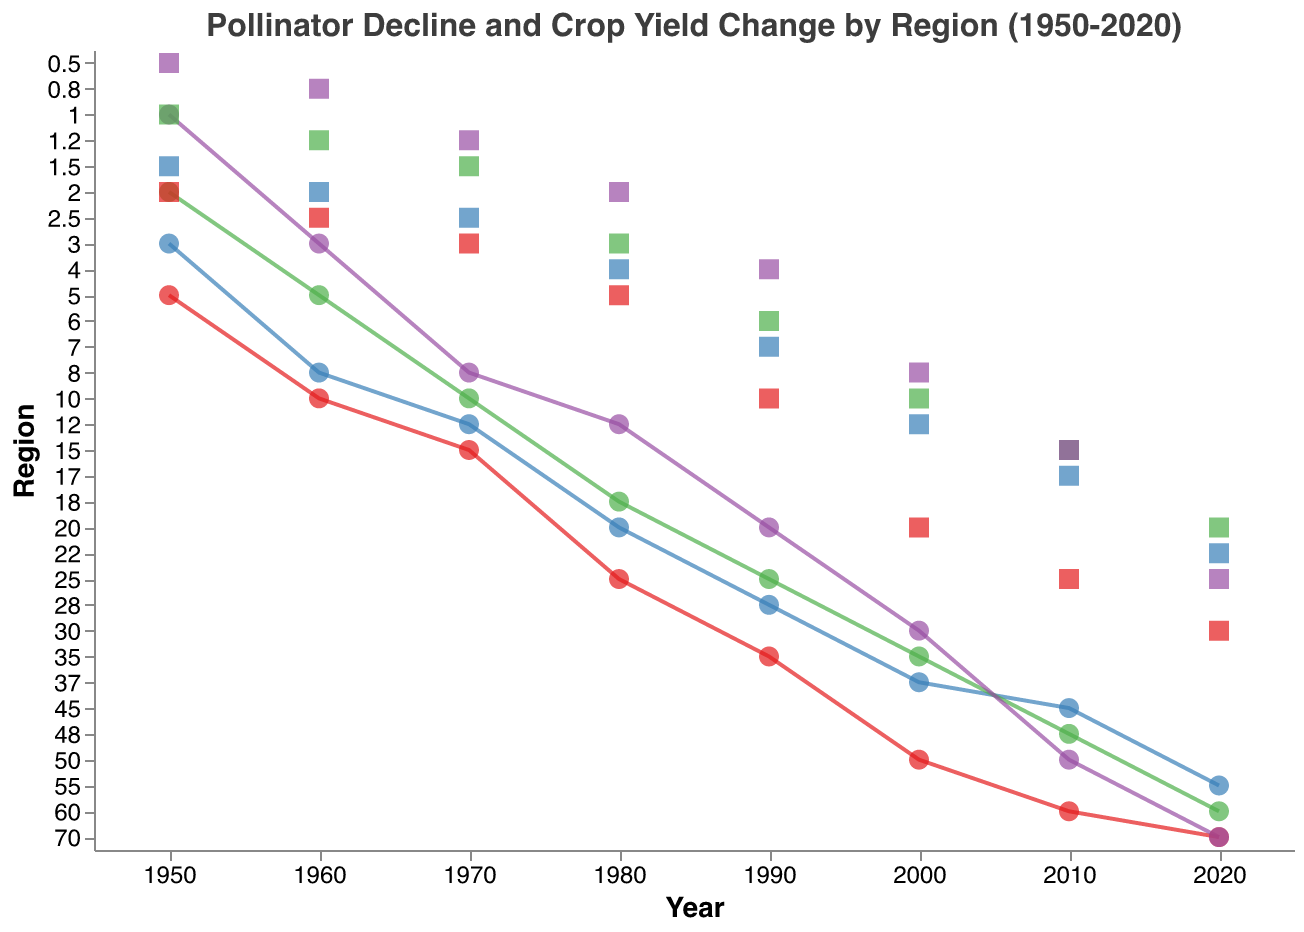What's the main title of the figure? The main title of the figure is located at the top and is descriptive of the content.
Answer: Pollinator Decline and Crop Yield Change by Region (1950-2020) What regions are compared in the figure? The figure utilizes distinct colors for different regions, which are listed as North America (red), Europe (blue), Asia (green), and Africa (purple).
Answer: North America, Europe, Asia, Africa Which region had the highest Pollinator Decline Rate in 2020? By examining the y-axis labeled "Pollinator Decline Rate" and the corresponding points for the year 2020, we can identify the highest value.
Answer: North America and Africa How does the Crop Yield Change in Africa in 1950 compare with its change in 2020? Locate the points representing Crop Yield Change in Africa for the years 1950 and 2020 on the y-axis and compare their values.
Answer: Increased from 0.5 to 25 Which region shows a steady increase in Crop Yield Change from 1950 to 2020? Look for regions where the Crop Yield Change increases consistently over a series of years marked by square points.
Answer: All regions show a steady increase Which two regions had a Pollinator Decline Rate of 70% in 2020? On the y-axis for the year 2020, find the point representing a Pollinator Decline Rate of 70% and identify the corresponding regions.
Answer: North America and Africa By how much did the Pollinator Decline Rate in Europe increase from 2000 to 2020? Find the Pollinator Decline Rate for Europe in 2000 and 2020, and calculate the difference between these values.
Answer: Increased by 18% Which region had the lowest Crop Yield Change in 1960? Examine the y-axis for Crop Yield Change points in 1960 and determine the region with the lowest value.
Answer: Africa In which year did North America see a Pollinator Decline Rate of over 50%? Track the trendline for North America and find the year where the Pollinator Decline Rate crossed the 50% mark.
Answer: 2000 